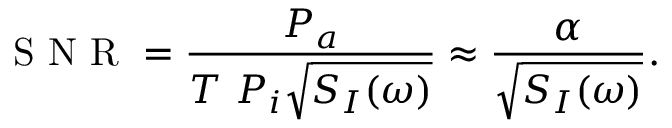Convert formula to latex. <formula><loc_0><loc_0><loc_500><loc_500>S N R = \frac { P _ { a } } { T \ P _ { i } \sqrt { S _ { I } ( \omega ) } } \approx \frac { \alpha } { \sqrt { S _ { I } ( \omega ) } } .</formula> 